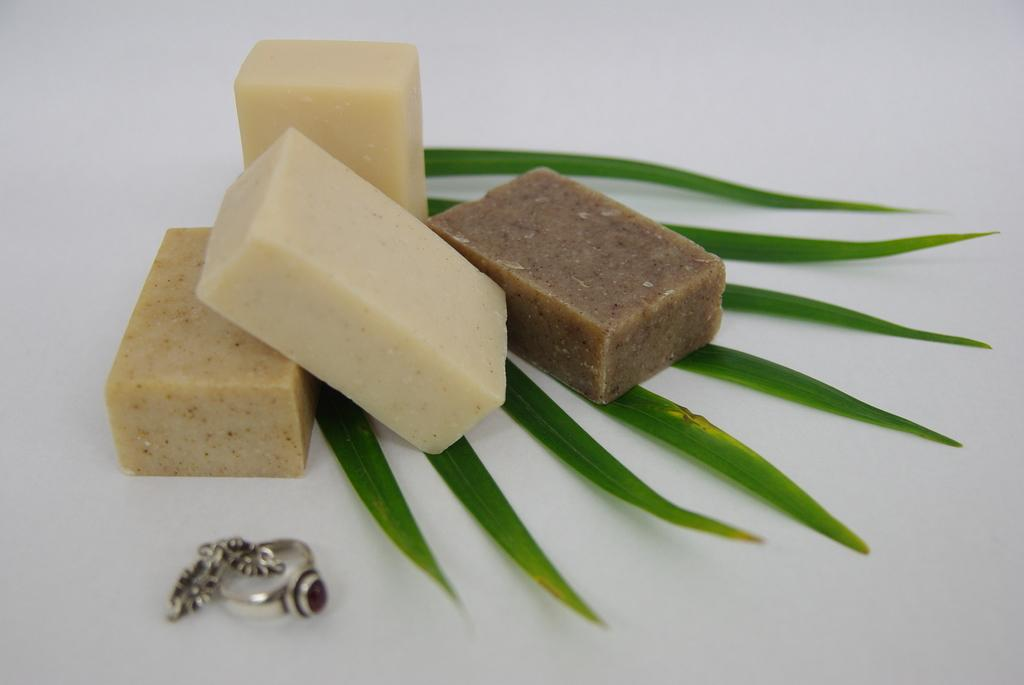What is located at the bottom of the image? There is a table at the bottom of the image. What items can be seen on the table? There are sweets, leaves, a ring, and earrings on the table. What type of jewelry is present on the table? There is a ring and earrings on the table. Is there a beggar asking for money on the table in the image? No, there is no beggar present in the image. How many clovers are on the table in the image? There are no clovers present in the image. 